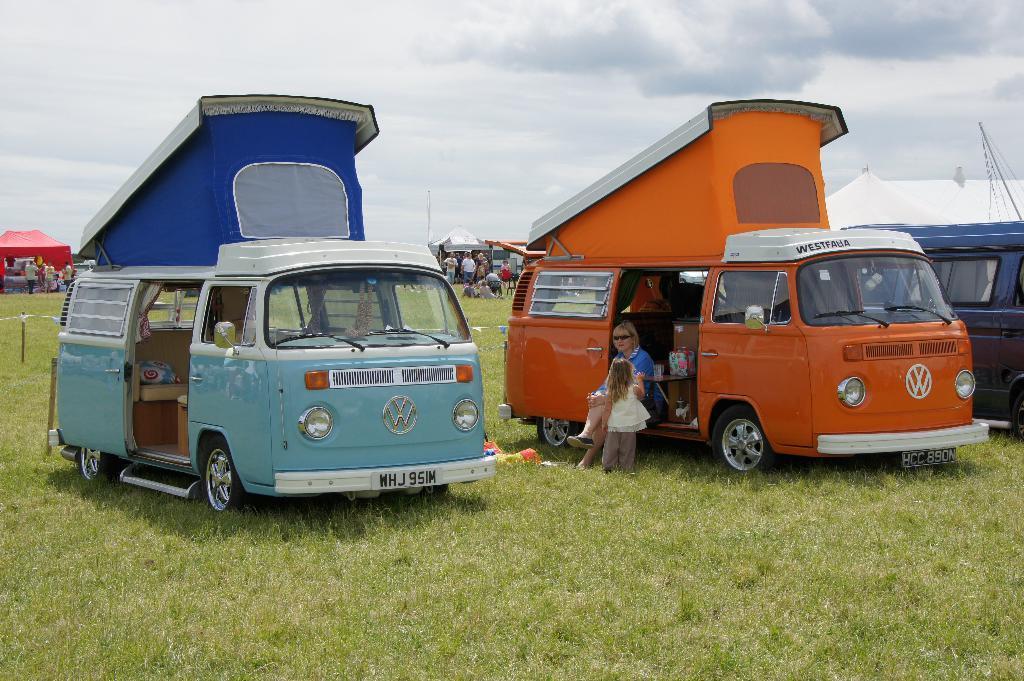In one or two sentences, can you explain what this image depicts? On the left side there is a van in blue color, on the right side there is another van in blue color, a woman is sitting on it. She wore blue color t-shirt and a baby is standing near to her. At the bottom it is the grass, at the top it is the cloudy sky. 